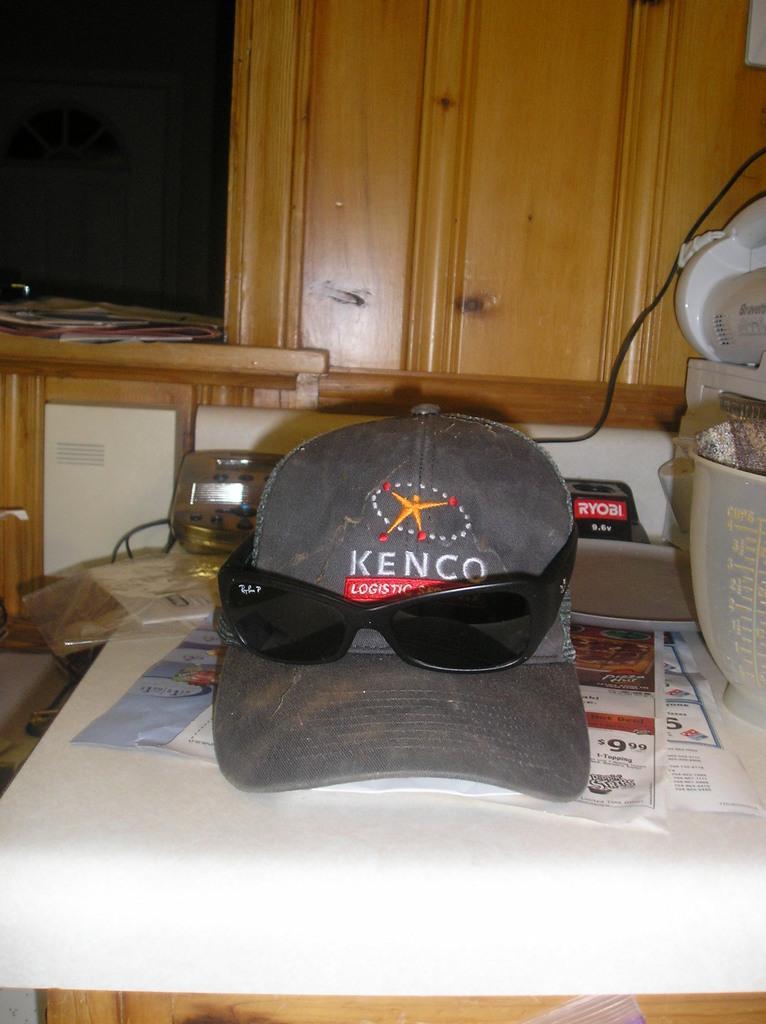Can you describe this image briefly? In this image we can see there is a table. On the table there is a cap, spectacles, bowl, paper, wire, brush and a few objects. And at the back there is a cupboard, on that the object looks like a file. 